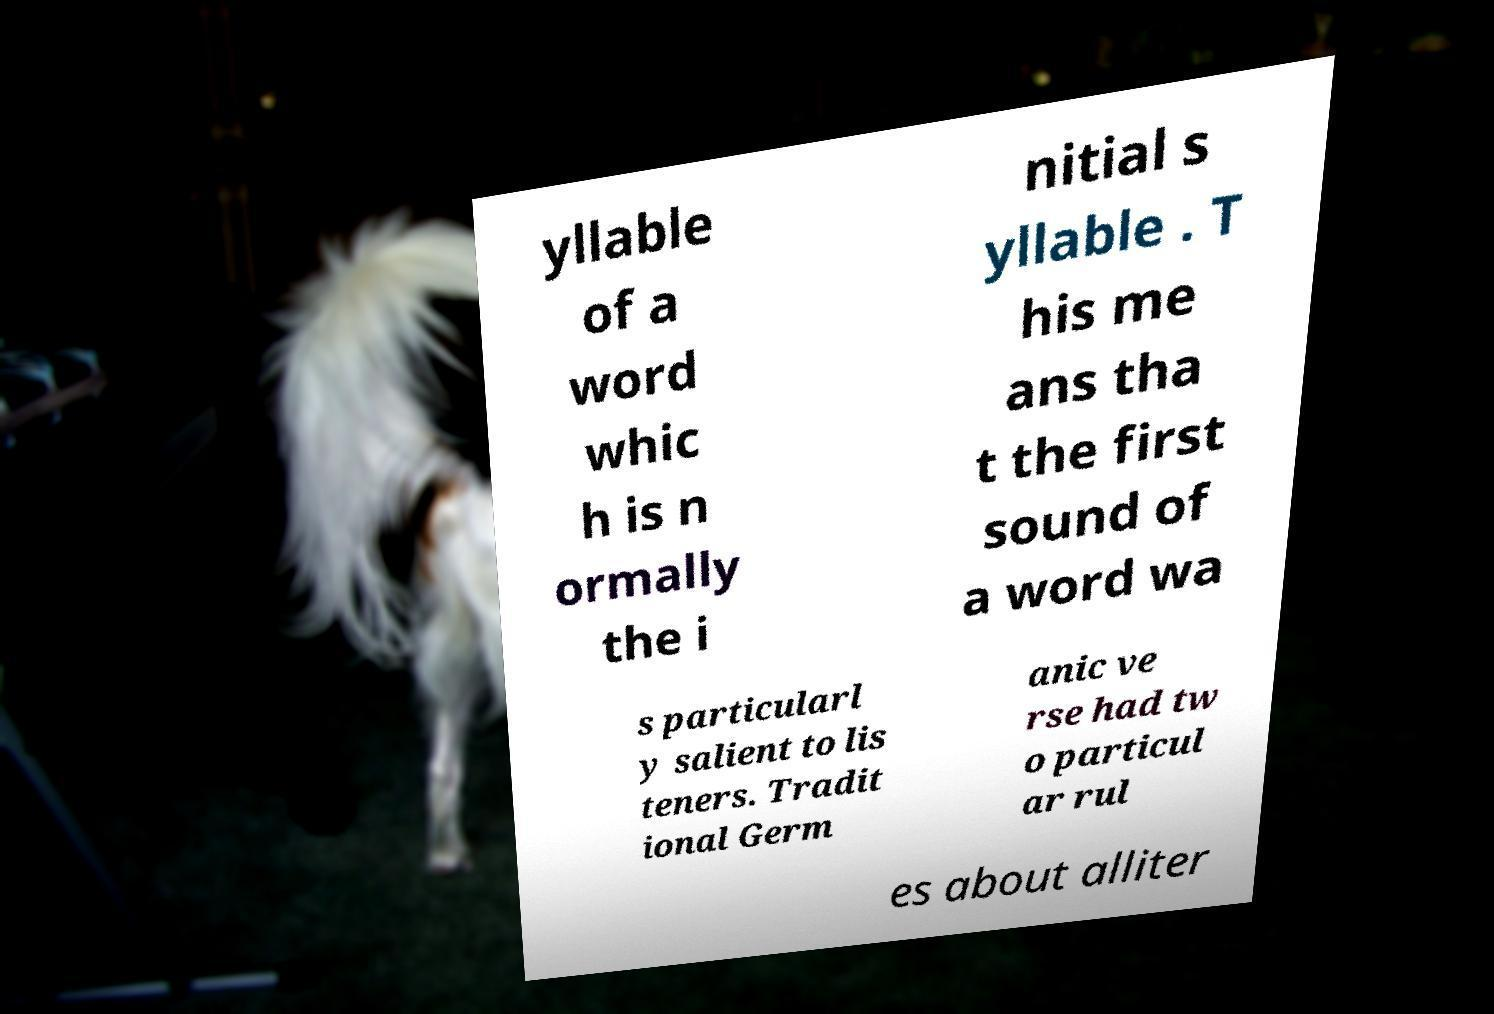I need the written content from this picture converted into text. Can you do that? yllable of a word whic h is n ormally the i nitial s yllable . T his me ans tha t the first sound of a word wa s particularl y salient to lis teners. Tradit ional Germ anic ve rse had tw o particul ar rul es about alliter 